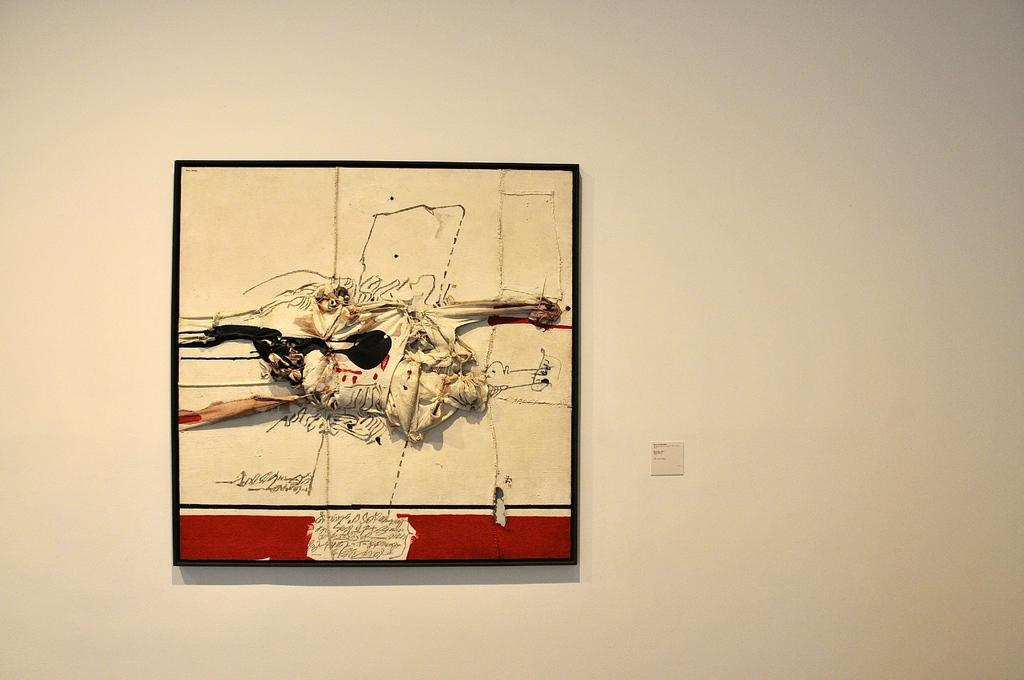What is the main object in the image? There is a frame in the image. What is inside the frame? The frame contains a painting. Is there any text associated with the frame? Yes, there is text at the bottom of the frame. Where is the frame located in the image? The frame is attached to a wall. How many vegetables are depicted in the painting inside the frame? There is no information about vegetables in the image, as the frame contains a painting and not a scene with vegetables. 